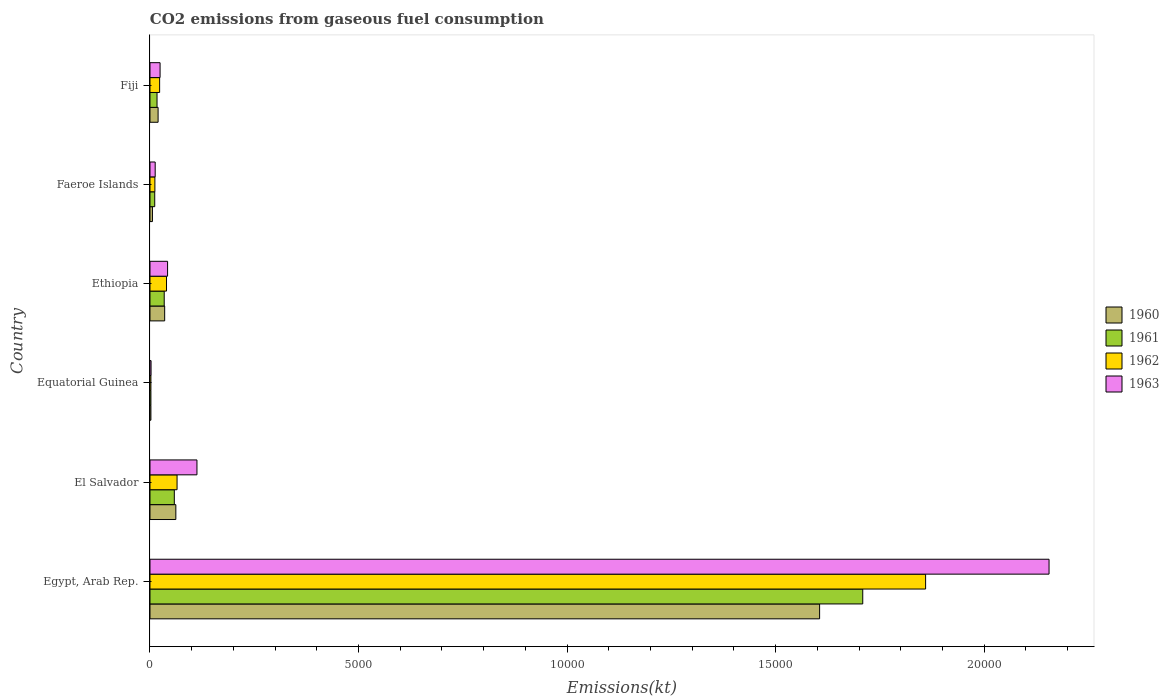Are the number of bars per tick equal to the number of legend labels?
Offer a terse response. Yes. How many bars are there on the 2nd tick from the bottom?
Your response must be concise. 4. What is the label of the 6th group of bars from the top?
Your answer should be very brief. Egypt, Arab Rep. In how many cases, is the number of bars for a given country not equal to the number of legend labels?
Offer a terse response. 0. What is the amount of CO2 emitted in 1961 in Egypt, Arab Rep.?
Offer a terse response. 1.71e+04. Across all countries, what is the maximum amount of CO2 emitted in 1960?
Offer a very short reply. 1.61e+04. Across all countries, what is the minimum amount of CO2 emitted in 1963?
Offer a terse response. 25.67. In which country was the amount of CO2 emitted in 1960 maximum?
Your answer should be very brief. Egypt, Arab Rep. In which country was the amount of CO2 emitted in 1962 minimum?
Offer a very short reply. Equatorial Guinea. What is the total amount of CO2 emitted in 1960 in the graph?
Your answer should be very brief. 1.73e+04. What is the difference between the amount of CO2 emitted in 1963 in Egypt, Arab Rep. and that in Fiji?
Offer a terse response. 2.13e+04. What is the difference between the amount of CO2 emitted in 1960 in Ethiopia and the amount of CO2 emitted in 1963 in Equatorial Guinea?
Your answer should be very brief. 326.36. What is the average amount of CO2 emitted in 1960 per country?
Your answer should be very brief. 2883.48. What is the difference between the amount of CO2 emitted in 1960 and amount of CO2 emitted in 1962 in Equatorial Guinea?
Provide a succinct answer. 0. In how many countries, is the amount of CO2 emitted in 1960 greater than 20000 kt?
Offer a terse response. 0. What is the ratio of the amount of CO2 emitted in 1961 in Equatorial Guinea to that in Ethiopia?
Give a very brief answer. 0.06. Is the difference between the amount of CO2 emitted in 1960 in Ethiopia and Faeroe Islands greater than the difference between the amount of CO2 emitted in 1962 in Ethiopia and Faeroe Islands?
Provide a short and direct response. Yes. What is the difference between the highest and the second highest amount of CO2 emitted in 1960?
Keep it short and to the point. 1.54e+04. What is the difference between the highest and the lowest amount of CO2 emitted in 1963?
Offer a very short reply. 2.15e+04. In how many countries, is the amount of CO2 emitted in 1961 greater than the average amount of CO2 emitted in 1961 taken over all countries?
Your response must be concise. 1. Is the sum of the amount of CO2 emitted in 1961 in El Salvador and Ethiopia greater than the maximum amount of CO2 emitted in 1963 across all countries?
Ensure brevity in your answer.  No. Is it the case that in every country, the sum of the amount of CO2 emitted in 1960 and amount of CO2 emitted in 1963 is greater than the sum of amount of CO2 emitted in 1961 and amount of CO2 emitted in 1962?
Provide a succinct answer. No. What does the 3rd bar from the top in Faeroe Islands represents?
Provide a short and direct response. 1961. Is it the case that in every country, the sum of the amount of CO2 emitted in 1960 and amount of CO2 emitted in 1962 is greater than the amount of CO2 emitted in 1961?
Your answer should be compact. Yes. How many bars are there?
Offer a very short reply. 24. What is the difference between two consecutive major ticks on the X-axis?
Your response must be concise. 5000. Are the values on the major ticks of X-axis written in scientific E-notation?
Your response must be concise. No. Does the graph contain any zero values?
Provide a succinct answer. No. Does the graph contain grids?
Offer a very short reply. No. Where does the legend appear in the graph?
Your response must be concise. Center right. How many legend labels are there?
Ensure brevity in your answer.  4. What is the title of the graph?
Your answer should be compact. CO2 emissions from gaseous fuel consumption. What is the label or title of the X-axis?
Ensure brevity in your answer.  Emissions(kt). What is the Emissions(kt) in 1960 in Egypt, Arab Rep.?
Your answer should be compact. 1.61e+04. What is the Emissions(kt) in 1961 in Egypt, Arab Rep.?
Make the answer very short. 1.71e+04. What is the Emissions(kt) in 1962 in Egypt, Arab Rep.?
Give a very brief answer. 1.86e+04. What is the Emissions(kt) of 1963 in Egypt, Arab Rep.?
Keep it short and to the point. 2.16e+04. What is the Emissions(kt) of 1960 in El Salvador?
Give a very brief answer. 619.72. What is the Emissions(kt) of 1961 in El Salvador?
Your response must be concise. 583.05. What is the Emissions(kt) of 1962 in El Salvador?
Your response must be concise. 649.06. What is the Emissions(kt) in 1963 in El Salvador?
Your answer should be very brief. 1125.77. What is the Emissions(kt) of 1960 in Equatorial Guinea?
Make the answer very short. 22. What is the Emissions(kt) in 1961 in Equatorial Guinea?
Your answer should be very brief. 22. What is the Emissions(kt) in 1962 in Equatorial Guinea?
Your answer should be very brief. 22. What is the Emissions(kt) of 1963 in Equatorial Guinea?
Your answer should be very brief. 25.67. What is the Emissions(kt) in 1960 in Ethiopia?
Offer a terse response. 352.03. What is the Emissions(kt) of 1961 in Ethiopia?
Provide a succinct answer. 341.03. What is the Emissions(kt) in 1962 in Ethiopia?
Keep it short and to the point. 396.04. What is the Emissions(kt) of 1963 in Ethiopia?
Make the answer very short. 421.7. What is the Emissions(kt) of 1960 in Faeroe Islands?
Offer a very short reply. 58.67. What is the Emissions(kt) in 1961 in Faeroe Islands?
Provide a short and direct response. 113.68. What is the Emissions(kt) in 1962 in Faeroe Islands?
Your answer should be very brief. 117.34. What is the Emissions(kt) in 1963 in Faeroe Islands?
Your response must be concise. 124.68. What is the Emissions(kt) in 1960 in Fiji?
Keep it short and to the point. 194.35. What is the Emissions(kt) in 1961 in Fiji?
Your answer should be compact. 168.68. What is the Emissions(kt) in 1962 in Fiji?
Offer a very short reply. 231.02. What is the Emissions(kt) in 1963 in Fiji?
Give a very brief answer. 242.02. Across all countries, what is the maximum Emissions(kt) in 1960?
Offer a very short reply. 1.61e+04. Across all countries, what is the maximum Emissions(kt) of 1961?
Provide a succinct answer. 1.71e+04. Across all countries, what is the maximum Emissions(kt) of 1962?
Provide a succinct answer. 1.86e+04. Across all countries, what is the maximum Emissions(kt) of 1963?
Offer a very short reply. 2.16e+04. Across all countries, what is the minimum Emissions(kt) in 1960?
Provide a short and direct response. 22. Across all countries, what is the minimum Emissions(kt) in 1961?
Provide a succinct answer. 22. Across all countries, what is the minimum Emissions(kt) in 1962?
Your answer should be very brief. 22. Across all countries, what is the minimum Emissions(kt) in 1963?
Give a very brief answer. 25.67. What is the total Emissions(kt) of 1960 in the graph?
Your response must be concise. 1.73e+04. What is the total Emissions(kt) in 1961 in the graph?
Make the answer very short. 1.83e+04. What is the total Emissions(kt) in 1962 in the graph?
Provide a short and direct response. 2.00e+04. What is the total Emissions(kt) of 1963 in the graph?
Your answer should be compact. 2.35e+04. What is the difference between the Emissions(kt) of 1960 in Egypt, Arab Rep. and that in El Salvador?
Provide a short and direct response. 1.54e+04. What is the difference between the Emissions(kt) in 1961 in Egypt, Arab Rep. and that in El Salvador?
Keep it short and to the point. 1.65e+04. What is the difference between the Emissions(kt) of 1962 in Egypt, Arab Rep. and that in El Salvador?
Your answer should be compact. 1.79e+04. What is the difference between the Emissions(kt) in 1963 in Egypt, Arab Rep. and that in El Salvador?
Offer a very short reply. 2.04e+04. What is the difference between the Emissions(kt) of 1960 in Egypt, Arab Rep. and that in Equatorial Guinea?
Ensure brevity in your answer.  1.60e+04. What is the difference between the Emissions(kt) in 1961 in Egypt, Arab Rep. and that in Equatorial Guinea?
Give a very brief answer. 1.71e+04. What is the difference between the Emissions(kt) in 1962 in Egypt, Arab Rep. and that in Equatorial Guinea?
Your answer should be very brief. 1.86e+04. What is the difference between the Emissions(kt) in 1963 in Egypt, Arab Rep. and that in Equatorial Guinea?
Your response must be concise. 2.15e+04. What is the difference between the Emissions(kt) in 1960 in Egypt, Arab Rep. and that in Ethiopia?
Offer a very short reply. 1.57e+04. What is the difference between the Emissions(kt) in 1961 in Egypt, Arab Rep. and that in Ethiopia?
Ensure brevity in your answer.  1.67e+04. What is the difference between the Emissions(kt) in 1962 in Egypt, Arab Rep. and that in Ethiopia?
Your response must be concise. 1.82e+04. What is the difference between the Emissions(kt) in 1963 in Egypt, Arab Rep. and that in Ethiopia?
Offer a very short reply. 2.11e+04. What is the difference between the Emissions(kt) of 1960 in Egypt, Arab Rep. and that in Faeroe Islands?
Offer a terse response. 1.60e+04. What is the difference between the Emissions(kt) in 1961 in Egypt, Arab Rep. and that in Faeroe Islands?
Ensure brevity in your answer.  1.70e+04. What is the difference between the Emissions(kt) in 1962 in Egypt, Arab Rep. and that in Faeroe Islands?
Give a very brief answer. 1.85e+04. What is the difference between the Emissions(kt) in 1963 in Egypt, Arab Rep. and that in Faeroe Islands?
Offer a very short reply. 2.14e+04. What is the difference between the Emissions(kt) in 1960 in Egypt, Arab Rep. and that in Fiji?
Your answer should be compact. 1.59e+04. What is the difference between the Emissions(kt) of 1961 in Egypt, Arab Rep. and that in Fiji?
Your answer should be compact. 1.69e+04. What is the difference between the Emissions(kt) of 1962 in Egypt, Arab Rep. and that in Fiji?
Give a very brief answer. 1.84e+04. What is the difference between the Emissions(kt) of 1963 in Egypt, Arab Rep. and that in Fiji?
Offer a terse response. 2.13e+04. What is the difference between the Emissions(kt) in 1960 in El Salvador and that in Equatorial Guinea?
Provide a short and direct response. 597.72. What is the difference between the Emissions(kt) in 1961 in El Salvador and that in Equatorial Guinea?
Offer a very short reply. 561.05. What is the difference between the Emissions(kt) in 1962 in El Salvador and that in Equatorial Guinea?
Keep it short and to the point. 627.06. What is the difference between the Emissions(kt) of 1963 in El Salvador and that in Equatorial Guinea?
Provide a succinct answer. 1100.1. What is the difference between the Emissions(kt) in 1960 in El Salvador and that in Ethiopia?
Your response must be concise. 267.69. What is the difference between the Emissions(kt) in 1961 in El Salvador and that in Ethiopia?
Make the answer very short. 242.02. What is the difference between the Emissions(kt) in 1962 in El Salvador and that in Ethiopia?
Your response must be concise. 253.02. What is the difference between the Emissions(kt) in 1963 in El Salvador and that in Ethiopia?
Your response must be concise. 704.06. What is the difference between the Emissions(kt) of 1960 in El Salvador and that in Faeroe Islands?
Ensure brevity in your answer.  561.05. What is the difference between the Emissions(kt) of 1961 in El Salvador and that in Faeroe Islands?
Your answer should be very brief. 469.38. What is the difference between the Emissions(kt) of 1962 in El Salvador and that in Faeroe Islands?
Keep it short and to the point. 531.72. What is the difference between the Emissions(kt) in 1963 in El Salvador and that in Faeroe Islands?
Offer a terse response. 1001.09. What is the difference between the Emissions(kt) in 1960 in El Salvador and that in Fiji?
Make the answer very short. 425.37. What is the difference between the Emissions(kt) in 1961 in El Salvador and that in Fiji?
Offer a terse response. 414.37. What is the difference between the Emissions(kt) in 1962 in El Salvador and that in Fiji?
Offer a very short reply. 418.04. What is the difference between the Emissions(kt) of 1963 in El Salvador and that in Fiji?
Your answer should be compact. 883.75. What is the difference between the Emissions(kt) in 1960 in Equatorial Guinea and that in Ethiopia?
Give a very brief answer. -330.03. What is the difference between the Emissions(kt) of 1961 in Equatorial Guinea and that in Ethiopia?
Give a very brief answer. -319.03. What is the difference between the Emissions(kt) in 1962 in Equatorial Guinea and that in Ethiopia?
Ensure brevity in your answer.  -374.03. What is the difference between the Emissions(kt) of 1963 in Equatorial Guinea and that in Ethiopia?
Provide a short and direct response. -396.04. What is the difference between the Emissions(kt) in 1960 in Equatorial Guinea and that in Faeroe Islands?
Give a very brief answer. -36.67. What is the difference between the Emissions(kt) in 1961 in Equatorial Guinea and that in Faeroe Islands?
Offer a very short reply. -91.67. What is the difference between the Emissions(kt) in 1962 in Equatorial Guinea and that in Faeroe Islands?
Give a very brief answer. -95.34. What is the difference between the Emissions(kt) in 1963 in Equatorial Guinea and that in Faeroe Islands?
Your response must be concise. -99.01. What is the difference between the Emissions(kt) of 1960 in Equatorial Guinea and that in Fiji?
Give a very brief answer. -172.35. What is the difference between the Emissions(kt) in 1961 in Equatorial Guinea and that in Fiji?
Ensure brevity in your answer.  -146.68. What is the difference between the Emissions(kt) in 1962 in Equatorial Guinea and that in Fiji?
Give a very brief answer. -209.02. What is the difference between the Emissions(kt) in 1963 in Equatorial Guinea and that in Fiji?
Offer a terse response. -216.35. What is the difference between the Emissions(kt) in 1960 in Ethiopia and that in Faeroe Islands?
Provide a short and direct response. 293.36. What is the difference between the Emissions(kt) in 1961 in Ethiopia and that in Faeroe Islands?
Provide a short and direct response. 227.35. What is the difference between the Emissions(kt) in 1962 in Ethiopia and that in Faeroe Islands?
Provide a short and direct response. 278.69. What is the difference between the Emissions(kt) in 1963 in Ethiopia and that in Faeroe Islands?
Your response must be concise. 297.03. What is the difference between the Emissions(kt) in 1960 in Ethiopia and that in Fiji?
Your answer should be compact. 157.68. What is the difference between the Emissions(kt) of 1961 in Ethiopia and that in Fiji?
Make the answer very short. 172.35. What is the difference between the Emissions(kt) in 1962 in Ethiopia and that in Fiji?
Make the answer very short. 165.01. What is the difference between the Emissions(kt) in 1963 in Ethiopia and that in Fiji?
Your answer should be compact. 179.68. What is the difference between the Emissions(kt) in 1960 in Faeroe Islands and that in Fiji?
Offer a terse response. -135.68. What is the difference between the Emissions(kt) in 1961 in Faeroe Islands and that in Fiji?
Make the answer very short. -55.01. What is the difference between the Emissions(kt) of 1962 in Faeroe Islands and that in Fiji?
Offer a terse response. -113.68. What is the difference between the Emissions(kt) of 1963 in Faeroe Islands and that in Fiji?
Your response must be concise. -117.34. What is the difference between the Emissions(kt) in 1960 in Egypt, Arab Rep. and the Emissions(kt) in 1961 in El Salvador?
Your response must be concise. 1.55e+04. What is the difference between the Emissions(kt) of 1960 in Egypt, Arab Rep. and the Emissions(kt) of 1962 in El Salvador?
Give a very brief answer. 1.54e+04. What is the difference between the Emissions(kt) in 1960 in Egypt, Arab Rep. and the Emissions(kt) in 1963 in El Salvador?
Your answer should be compact. 1.49e+04. What is the difference between the Emissions(kt) of 1961 in Egypt, Arab Rep. and the Emissions(kt) of 1962 in El Salvador?
Keep it short and to the point. 1.64e+04. What is the difference between the Emissions(kt) of 1961 in Egypt, Arab Rep. and the Emissions(kt) of 1963 in El Salvador?
Give a very brief answer. 1.60e+04. What is the difference between the Emissions(kt) of 1962 in Egypt, Arab Rep. and the Emissions(kt) of 1963 in El Salvador?
Ensure brevity in your answer.  1.75e+04. What is the difference between the Emissions(kt) in 1960 in Egypt, Arab Rep. and the Emissions(kt) in 1961 in Equatorial Guinea?
Your answer should be compact. 1.60e+04. What is the difference between the Emissions(kt) of 1960 in Egypt, Arab Rep. and the Emissions(kt) of 1962 in Equatorial Guinea?
Offer a terse response. 1.60e+04. What is the difference between the Emissions(kt) of 1960 in Egypt, Arab Rep. and the Emissions(kt) of 1963 in Equatorial Guinea?
Offer a very short reply. 1.60e+04. What is the difference between the Emissions(kt) in 1961 in Egypt, Arab Rep. and the Emissions(kt) in 1962 in Equatorial Guinea?
Your response must be concise. 1.71e+04. What is the difference between the Emissions(kt) in 1961 in Egypt, Arab Rep. and the Emissions(kt) in 1963 in Equatorial Guinea?
Your response must be concise. 1.71e+04. What is the difference between the Emissions(kt) in 1962 in Egypt, Arab Rep. and the Emissions(kt) in 1963 in Equatorial Guinea?
Your response must be concise. 1.86e+04. What is the difference between the Emissions(kt) of 1960 in Egypt, Arab Rep. and the Emissions(kt) of 1961 in Ethiopia?
Your answer should be compact. 1.57e+04. What is the difference between the Emissions(kt) of 1960 in Egypt, Arab Rep. and the Emissions(kt) of 1962 in Ethiopia?
Offer a terse response. 1.57e+04. What is the difference between the Emissions(kt) in 1960 in Egypt, Arab Rep. and the Emissions(kt) in 1963 in Ethiopia?
Give a very brief answer. 1.56e+04. What is the difference between the Emissions(kt) in 1961 in Egypt, Arab Rep. and the Emissions(kt) in 1962 in Ethiopia?
Keep it short and to the point. 1.67e+04. What is the difference between the Emissions(kt) in 1961 in Egypt, Arab Rep. and the Emissions(kt) in 1963 in Ethiopia?
Keep it short and to the point. 1.67e+04. What is the difference between the Emissions(kt) of 1962 in Egypt, Arab Rep. and the Emissions(kt) of 1963 in Ethiopia?
Ensure brevity in your answer.  1.82e+04. What is the difference between the Emissions(kt) of 1960 in Egypt, Arab Rep. and the Emissions(kt) of 1961 in Faeroe Islands?
Offer a terse response. 1.59e+04. What is the difference between the Emissions(kt) of 1960 in Egypt, Arab Rep. and the Emissions(kt) of 1962 in Faeroe Islands?
Offer a very short reply. 1.59e+04. What is the difference between the Emissions(kt) of 1960 in Egypt, Arab Rep. and the Emissions(kt) of 1963 in Faeroe Islands?
Your answer should be compact. 1.59e+04. What is the difference between the Emissions(kt) in 1961 in Egypt, Arab Rep. and the Emissions(kt) in 1962 in Faeroe Islands?
Offer a terse response. 1.70e+04. What is the difference between the Emissions(kt) in 1961 in Egypt, Arab Rep. and the Emissions(kt) in 1963 in Faeroe Islands?
Your answer should be compact. 1.70e+04. What is the difference between the Emissions(kt) in 1962 in Egypt, Arab Rep. and the Emissions(kt) in 1963 in Faeroe Islands?
Provide a short and direct response. 1.85e+04. What is the difference between the Emissions(kt) in 1960 in Egypt, Arab Rep. and the Emissions(kt) in 1961 in Fiji?
Provide a short and direct response. 1.59e+04. What is the difference between the Emissions(kt) in 1960 in Egypt, Arab Rep. and the Emissions(kt) in 1962 in Fiji?
Your answer should be compact. 1.58e+04. What is the difference between the Emissions(kt) in 1960 in Egypt, Arab Rep. and the Emissions(kt) in 1963 in Fiji?
Provide a short and direct response. 1.58e+04. What is the difference between the Emissions(kt) in 1961 in Egypt, Arab Rep. and the Emissions(kt) in 1962 in Fiji?
Ensure brevity in your answer.  1.69e+04. What is the difference between the Emissions(kt) of 1961 in Egypt, Arab Rep. and the Emissions(kt) of 1963 in Fiji?
Provide a short and direct response. 1.68e+04. What is the difference between the Emissions(kt) of 1962 in Egypt, Arab Rep. and the Emissions(kt) of 1963 in Fiji?
Offer a terse response. 1.84e+04. What is the difference between the Emissions(kt) in 1960 in El Salvador and the Emissions(kt) in 1961 in Equatorial Guinea?
Offer a terse response. 597.72. What is the difference between the Emissions(kt) in 1960 in El Salvador and the Emissions(kt) in 1962 in Equatorial Guinea?
Provide a short and direct response. 597.72. What is the difference between the Emissions(kt) in 1960 in El Salvador and the Emissions(kt) in 1963 in Equatorial Guinea?
Your response must be concise. 594.05. What is the difference between the Emissions(kt) of 1961 in El Salvador and the Emissions(kt) of 1962 in Equatorial Guinea?
Make the answer very short. 561.05. What is the difference between the Emissions(kt) of 1961 in El Salvador and the Emissions(kt) of 1963 in Equatorial Guinea?
Your answer should be very brief. 557.38. What is the difference between the Emissions(kt) in 1962 in El Salvador and the Emissions(kt) in 1963 in Equatorial Guinea?
Your answer should be very brief. 623.39. What is the difference between the Emissions(kt) of 1960 in El Salvador and the Emissions(kt) of 1961 in Ethiopia?
Give a very brief answer. 278.69. What is the difference between the Emissions(kt) of 1960 in El Salvador and the Emissions(kt) of 1962 in Ethiopia?
Your response must be concise. 223.69. What is the difference between the Emissions(kt) in 1960 in El Salvador and the Emissions(kt) in 1963 in Ethiopia?
Ensure brevity in your answer.  198.02. What is the difference between the Emissions(kt) of 1961 in El Salvador and the Emissions(kt) of 1962 in Ethiopia?
Make the answer very short. 187.02. What is the difference between the Emissions(kt) in 1961 in El Salvador and the Emissions(kt) in 1963 in Ethiopia?
Make the answer very short. 161.35. What is the difference between the Emissions(kt) of 1962 in El Salvador and the Emissions(kt) of 1963 in Ethiopia?
Offer a very short reply. 227.35. What is the difference between the Emissions(kt) of 1960 in El Salvador and the Emissions(kt) of 1961 in Faeroe Islands?
Your response must be concise. 506.05. What is the difference between the Emissions(kt) in 1960 in El Salvador and the Emissions(kt) in 1962 in Faeroe Islands?
Ensure brevity in your answer.  502.38. What is the difference between the Emissions(kt) of 1960 in El Salvador and the Emissions(kt) of 1963 in Faeroe Islands?
Provide a short and direct response. 495.05. What is the difference between the Emissions(kt) of 1961 in El Salvador and the Emissions(kt) of 1962 in Faeroe Islands?
Provide a short and direct response. 465.71. What is the difference between the Emissions(kt) of 1961 in El Salvador and the Emissions(kt) of 1963 in Faeroe Islands?
Your answer should be very brief. 458.38. What is the difference between the Emissions(kt) in 1962 in El Salvador and the Emissions(kt) in 1963 in Faeroe Islands?
Your answer should be very brief. 524.38. What is the difference between the Emissions(kt) in 1960 in El Salvador and the Emissions(kt) in 1961 in Fiji?
Your answer should be compact. 451.04. What is the difference between the Emissions(kt) in 1960 in El Salvador and the Emissions(kt) in 1962 in Fiji?
Your answer should be very brief. 388.7. What is the difference between the Emissions(kt) of 1960 in El Salvador and the Emissions(kt) of 1963 in Fiji?
Provide a succinct answer. 377.7. What is the difference between the Emissions(kt) in 1961 in El Salvador and the Emissions(kt) in 1962 in Fiji?
Ensure brevity in your answer.  352.03. What is the difference between the Emissions(kt) in 1961 in El Salvador and the Emissions(kt) in 1963 in Fiji?
Ensure brevity in your answer.  341.03. What is the difference between the Emissions(kt) in 1962 in El Salvador and the Emissions(kt) in 1963 in Fiji?
Your response must be concise. 407.04. What is the difference between the Emissions(kt) of 1960 in Equatorial Guinea and the Emissions(kt) of 1961 in Ethiopia?
Your response must be concise. -319.03. What is the difference between the Emissions(kt) in 1960 in Equatorial Guinea and the Emissions(kt) in 1962 in Ethiopia?
Your answer should be compact. -374.03. What is the difference between the Emissions(kt) of 1960 in Equatorial Guinea and the Emissions(kt) of 1963 in Ethiopia?
Ensure brevity in your answer.  -399.7. What is the difference between the Emissions(kt) in 1961 in Equatorial Guinea and the Emissions(kt) in 1962 in Ethiopia?
Offer a very short reply. -374.03. What is the difference between the Emissions(kt) in 1961 in Equatorial Guinea and the Emissions(kt) in 1963 in Ethiopia?
Give a very brief answer. -399.7. What is the difference between the Emissions(kt) of 1962 in Equatorial Guinea and the Emissions(kt) of 1963 in Ethiopia?
Keep it short and to the point. -399.7. What is the difference between the Emissions(kt) of 1960 in Equatorial Guinea and the Emissions(kt) of 1961 in Faeroe Islands?
Ensure brevity in your answer.  -91.67. What is the difference between the Emissions(kt) of 1960 in Equatorial Guinea and the Emissions(kt) of 1962 in Faeroe Islands?
Offer a very short reply. -95.34. What is the difference between the Emissions(kt) in 1960 in Equatorial Guinea and the Emissions(kt) in 1963 in Faeroe Islands?
Provide a succinct answer. -102.68. What is the difference between the Emissions(kt) in 1961 in Equatorial Guinea and the Emissions(kt) in 1962 in Faeroe Islands?
Provide a short and direct response. -95.34. What is the difference between the Emissions(kt) in 1961 in Equatorial Guinea and the Emissions(kt) in 1963 in Faeroe Islands?
Keep it short and to the point. -102.68. What is the difference between the Emissions(kt) in 1962 in Equatorial Guinea and the Emissions(kt) in 1963 in Faeroe Islands?
Make the answer very short. -102.68. What is the difference between the Emissions(kt) of 1960 in Equatorial Guinea and the Emissions(kt) of 1961 in Fiji?
Provide a short and direct response. -146.68. What is the difference between the Emissions(kt) of 1960 in Equatorial Guinea and the Emissions(kt) of 1962 in Fiji?
Offer a very short reply. -209.02. What is the difference between the Emissions(kt) in 1960 in Equatorial Guinea and the Emissions(kt) in 1963 in Fiji?
Offer a terse response. -220.02. What is the difference between the Emissions(kt) of 1961 in Equatorial Guinea and the Emissions(kt) of 1962 in Fiji?
Ensure brevity in your answer.  -209.02. What is the difference between the Emissions(kt) of 1961 in Equatorial Guinea and the Emissions(kt) of 1963 in Fiji?
Make the answer very short. -220.02. What is the difference between the Emissions(kt) in 1962 in Equatorial Guinea and the Emissions(kt) in 1963 in Fiji?
Provide a short and direct response. -220.02. What is the difference between the Emissions(kt) in 1960 in Ethiopia and the Emissions(kt) in 1961 in Faeroe Islands?
Provide a succinct answer. 238.35. What is the difference between the Emissions(kt) of 1960 in Ethiopia and the Emissions(kt) of 1962 in Faeroe Islands?
Offer a very short reply. 234.69. What is the difference between the Emissions(kt) in 1960 in Ethiopia and the Emissions(kt) in 1963 in Faeroe Islands?
Your response must be concise. 227.35. What is the difference between the Emissions(kt) of 1961 in Ethiopia and the Emissions(kt) of 1962 in Faeroe Islands?
Your answer should be compact. 223.69. What is the difference between the Emissions(kt) of 1961 in Ethiopia and the Emissions(kt) of 1963 in Faeroe Islands?
Provide a short and direct response. 216.35. What is the difference between the Emissions(kt) of 1962 in Ethiopia and the Emissions(kt) of 1963 in Faeroe Islands?
Make the answer very short. 271.36. What is the difference between the Emissions(kt) in 1960 in Ethiopia and the Emissions(kt) in 1961 in Fiji?
Your answer should be compact. 183.35. What is the difference between the Emissions(kt) of 1960 in Ethiopia and the Emissions(kt) of 1962 in Fiji?
Ensure brevity in your answer.  121.01. What is the difference between the Emissions(kt) in 1960 in Ethiopia and the Emissions(kt) in 1963 in Fiji?
Offer a terse response. 110.01. What is the difference between the Emissions(kt) of 1961 in Ethiopia and the Emissions(kt) of 1962 in Fiji?
Make the answer very short. 110.01. What is the difference between the Emissions(kt) in 1961 in Ethiopia and the Emissions(kt) in 1963 in Fiji?
Keep it short and to the point. 99.01. What is the difference between the Emissions(kt) of 1962 in Ethiopia and the Emissions(kt) of 1963 in Fiji?
Make the answer very short. 154.01. What is the difference between the Emissions(kt) in 1960 in Faeroe Islands and the Emissions(kt) in 1961 in Fiji?
Ensure brevity in your answer.  -110.01. What is the difference between the Emissions(kt) in 1960 in Faeroe Islands and the Emissions(kt) in 1962 in Fiji?
Your response must be concise. -172.35. What is the difference between the Emissions(kt) in 1960 in Faeroe Islands and the Emissions(kt) in 1963 in Fiji?
Your answer should be very brief. -183.35. What is the difference between the Emissions(kt) of 1961 in Faeroe Islands and the Emissions(kt) of 1962 in Fiji?
Your response must be concise. -117.34. What is the difference between the Emissions(kt) in 1961 in Faeroe Islands and the Emissions(kt) in 1963 in Fiji?
Keep it short and to the point. -128.34. What is the difference between the Emissions(kt) of 1962 in Faeroe Islands and the Emissions(kt) of 1963 in Fiji?
Make the answer very short. -124.68. What is the average Emissions(kt) of 1960 per country?
Make the answer very short. 2883.48. What is the average Emissions(kt) of 1961 per country?
Your answer should be very brief. 3052.78. What is the average Emissions(kt) in 1962 per country?
Your answer should be compact. 3335.14. What is the average Emissions(kt) of 1963 per country?
Make the answer very short. 3915.74. What is the difference between the Emissions(kt) of 1960 and Emissions(kt) of 1961 in Egypt, Arab Rep.?
Give a very brief answer. -1034.09. What is the difference between the Emissions(kt) in 1960 and Emissions(kt) in 1962 in Egypt, Arab Rep.?
Ensure brevity in your answer.  -2541.23. What is the difference between the Emissions(kt) in 1960 and Emissions(kt) in 1963 in Egypt, Arab Rep.?
Your response must be concise. -5500.5. What is the difference between the Emissions(kt) of 1961 and Emissions(kt) of 1962 in Egypt, Arab Rep.?
Offer a terse response. -1507.14. What is the difference between the Emissions(kt) in 1961 and Emissions(kt) in 1963 in Egypt, Arab Rep.?
Your answer should be very brief. -4466.41. What is the difference between the Emissions(kt) of 1962 and Emissions(kt) of 1963 in Egypt, Arab Rep.?
Your answer should be compact. -2959.27. What is the difference between the Emissions(kt) of 1960 and Emissions(kt) of 1961 in El Salvador?
Provide a short and direct response. 36.67. What is the difference between the Emissions(kt) in 1960 and Emissions(kt) in 1962 in El Salvador?
Offer a very short reply. -29.34. What is the difference between the Emissions(kt) of 1960 and Emissions(kt) of 1963 in El Salvador?
Give a very brief answer. -506.05. What is the difference between the Emissions(kt) of 1961 and Emissions(kt) of 1962 in El Salvador?
Offer a terse response. -66.01. What is the difference between the Emissions(kt) in 1961 and Emissions(kt) in 1963 in El Salvador?
Give a very brief answer. -542.72. What is the difference between the Emissions(kt) in 1962 and Emissions(kt) in 1963 in El Salvador?
Provide a succinct answer. -476.71. What is the difference between the Emissions(kt) of 1960 and Emissions(kt) of 1961 in Equatorial Guinea?
Provide a short and direct response. 0. What is the difference between the Emissions(kt) in 1960 and Emissions(kt) in 1963 in Equatorial Guinea?
Your response must be concise. -3.67. What is the difference between the Emissions(kt) in 1961 and Emissions(kt) in 1962 in Equatorial Guinea?
Your answer should be very brief. 0. What is the difference between the Emissions(kt) of 1961 and Emissions(kt) of 1963 in Equatorial Guinea?
Provide a succinct answer. -3.67. What is the difference between the Emissions(kt) in 1962 and Emissions(kt) in 1963 in Equatorial Guinea?
Your answer should be compact. -3.67. What is the difference between the Emissions(kt) in 1960 and Emissions(kt) in 1961 in Ethiopia?
Ensure brevity in your answer.  11. What is the difference between the Emissions(kt) of 1960 and Emissions(kt) of 1962 in Ethiopia?
Provide a short and direct response. -44. What is the difference between the Emissions(kt) in 1960 and Emissions(kt) in 1963 in Ethiopia?
Give a very brief answer. -69.67. What is the difference between the Emissions(kt) in 1961 and Emissions(kt) in 1962 in Ethiopia?
Your response must be concise. -55.01. What is the difference between the Emissions(kt) of 1961 and Emissions(kt) of 1963 in Ethiopia?
Provide a short and direct response. -80.67. What is the difference between the Emissions(kt) in 1962 and Emissions(kt) in 1963 in Ethiopia?
Provide a succinct answer. -25.67. What is the difference between the Emissions(kt) of 1960 and Emissions(kt) of 1961 in Faeroe Islands?
Provide a succinct answer. -55.01. What is the difference between the Emissions(kt) in 1960 and Emissions(kt) in 1962 in Faeroe Islands?
Offer a very short reply. -58.67. What is the difference between the Emissions(kt) in 1960 and Emissions(kt) in 1963 in Faeroe Islands?
Offer a terse response. -66.01. What is the difference between the Emissions(kt) of 1961 and Emissions(kt) of 1962 in Faeroe Islands?
Your response must be concise. -3.67. What is the difference between the Emissions(kt) in 1961 and Emissions(kt) in 1963 in Faeroe Islands?
Ensure brevity in your answer.  -11. What is the difference between the Emissions(kt) in 1962 and Emissions(kt) in 1963 in Faeroe Islands?
Offer a very short reply. -7.33. What is the difference between the Emissions(kt) of 1960 and Emissions(kt) of 1961 in Fiji?
Keep it short and to the point. 25.67. What is the difference between the Emissions(kt) of 1960 and Emissions(kt) of 1962 in Fiji?
Offer a very short reply. -36.67. What is the difference between the Emissions(kt) in 1960 and Emissions(kt) in 1963 in Fiji?
Provide a short and direct response. -47.67. What is the difference between the Emissions(kt) in 1961 and Emissions(kt) in 1962 in Fiji?
Make the answer very short. -62.34. What is the difference between the Emissions(kt) of 1961 and Emissions(kt) of 1963 in Fiji?
Your response must be concise. -73.34. What is the difference between the Emissions(kt) of 1962 and Emissions(kt) of 1963 in Fiji?
Give a very brief answer. -11. What is the ratio of the Emissions(kt) of 1960 in Egypt, Arab Rep. to that in El Salvador?
Your answer should be compact. 25.91. What is the ratio of the Emissions(kt) in 1961 in Egypt, Arab Rep. to that in El Salvador?
Provide a succinct answer. 29.31. What is the ratio of the Emissions(kt) in 1962 in Egypt, Arab Rep. to that in El Salvador?
Offer a very short reply. 28.65. What is the ratio of the Emissions(kt) of 1963 in Egypt, Arab Rep. to that in El Salvador?
Ensure brevity in your answer.  19.15. What is the ratio of the Emissions(kt) of 1960 in Egypt, Arab Rep. to that in Equatorial Guinea?
Give a very brief answer. 729.67. What is the ratio of the Emissions(kt) in 1961 in Egypt, Arab Rep. to that in Equatorial Guinea?
Provide a short and direct response. 776.67. What is the ratio of the Emissions(kt) of 1962 in Egypt, Arab Rep. to that in Equatorial Guinea?
Ensure brevity in your answer.  845.17. What is the ratio of the Emissions(kt) in 1963 in Egypt, Arab Rep. to that in Equatorial Guinea?
Provide a short and direct response. 839.71. What is the ratio of the Emissions(kt) in 1960 in Egypt, Arab Rep. to that in Ethiopia?
Provide a short and direct response. 45.6. What is the ratio of the Emissions(kt) of 1961 in Egypt, Arab Rep. to that in Ethiopia?
Provide a succinct answer. 50.11. What is the ratio of the Emissions(kt) in 1962 in Egypt, Arab Rep. to that in Ethiopia?
Provide a short and direct response. 46.95. What is the ratio of the Emissions(kt) in 1963 in Egypt, Arab Rep. to that in Ethiopia?
Provide a short and direct response. 51.11. What is the ratio of the Emissions(kt) in 1960 in Egypt, Arab Rep. to that in Faeroe Islands?
Your answer should be very brief. 273.62. What is the ratio of the Emissions(kt) in 1961 in Egypt, Arab Rep. to that in Faeroe Islands?
Give a very brief answer. 150.32. What is the ratio of the Emissions(kt) in 1962 in Egypt, Arab Rep. to that in Faeroe Islands?
Offer a terse response. 158.47. What is the ratio of the Emissions(kt) of 1963 in Egypt, Arab Rep. to that in Faeroe Islands?
Ensure brevity in your answer.  172.88. What is the ratio of the Emissions(kt) in 1960 in Egypt, Arab Rep. to that in Fiji?
Offer a terse response. 82.6. What is the ratio of the Emissions(kt) of 1961 in Egypt, Arab Rep. to that in Fiji?
Keep it short and to the point. 101.3. What is the ratio of the Emissions(kt) of 1962 in Egypt, Arab Rep. to that in Fiji?
Ensure brevity in your answer.  80.49. What is the ratio of the Emissions(kt) of 1963 in Egypt, Arab Rep. to that in Fiji?
Make the answer very short. 89.06. What is the ratio of the Emissions(kt) in 1960 in El Salvador to that in Equatorial Guinea?
Your answer should be compact. 28.17. What is the ratio of the Emissions(kt) in 1961 in El Salvador to that in Equatorial Guinea?
Your answer should be compact. 26.5. What is the ratio of the Emissions(kt) of 1962 in El Salvador to that in Equatorial Guinea?
Provide a succinct answer. 29.5. What is the ratio of the Emissions(kt) in 1963 in El Salvador to that in Equatorial Guinea?
Give a very brief answer. 43.86. What is the ratio of the Emissions(kt) of 1960 in El Salvador to that in Ethiopia?
Provide a short and direct response. 1.76. What is the ratio of the Emissions(kt) in 1961 in El Salvador to that in Ethiopia?
Your answer should be very brief. 1.71. What is the ratio of the Emissions(kt) of 1962 in El Salvador to that in Ethiopia?
Give a very brief answer. 1.64. What is the ratio of the Emissions(kt) of 1963 in El Salvador to that in Ethiopia?
Make the answer very short. 2.67. What is the ratio of the Emissions(kt) in 1960 in El Salvador to that in Faeroe Islands?
Offer a very short reply. 10.56. What is the ratio of the Emissions(kt) of 1961 in El Salvador to that in Faeroe Islands?
Provide a short and direct response. 5.13. What is the ratio of the Emissions(kt) in 1962 in El Salvador to that in Faeroe Islands?
Your answer should be very brief. 5.53. What is the ratio of the Emissions(kt) in 1963 in El Salvador to that in Faeroe Islands?
Make the answer very short. 9.03. What is the ratio of the Emissions(kt) of 1960 in El Salvador to that in Fiji?
Your answer should be compact. 3.19. What is the ratio of the Emissions(kt) of 1961 in El Salvador to that in Fiji?
Your response must be concise. 3.46. What is the ratio of the Emissions(kt) in 1962 in El Salvador to that in Fiji?
Give a very brief answer. 2.81. What is the ratio of the Emissions(kt) of 1963 in El Salvador to that in Fiji?
Make the answer very short. 4.65. What is the ratio of the Emissions(kt) in 1960 in Equatorial Guinea to that in Ethiopia?
Your response must be concise. 0.06. What is the ratio of the Emissions(kt) of 1961 in Equatorial Guinea to that in Ethiopia?
Your answer should be very brief. 0.06. What is the ratio of the Emissions(kt) in 1962 in Equatorial Guinea to that in Ethiopia?
Keep it short and to the point. 0.06. What is the ratio of the Emissions(kt) in 1963 in Equatorial Guinea to that in Ethiopia?
Make the answer very short. 0.06. What is the ratio of the Emissions(kt) in 1960 in Equatorial Guinea to that in Faeroe Islands?
Offer a very short reply. 0.38. What is the ratio of the Emissions(kt) of 1961 in Equatorial Guinea to that in Faeroe Islands?
Your answer should be very brief. 0.19. What is the ratio of the Emissions(kt) in 1962 in Equatorial Guinea to that in Faeroe Islands?
Provide a short and direct response. 0.19. What is the ratio of the Emissions(kt) in 1963 in Equatorial Guinea to that in Faeroe Islands?
Make the answer very short. 0.21. What is the ratio of the Emissions(kt) in 1960 in Equatorial Guinea to that in Fiji?
Your response must be concise. 0.11. What is the ratio of the Emissions(kt) of 1961 in Equatorial Guinea to that in Fiji?
Ensure brevity in your answer.  0.13. What is the ratio of the Emissions(kt) in 1962 in Equatorial Guinea to that in Fiji?
Provide a succinct answer. 0.1. What is the ratio of the Emissions(kt) in 1963 in Equatorial Guinea to that in Fiji?
Make the answer very short. 0.11. What is the ratio of the Emissions(kt) in 1960 in Ethiopia to that in Faeroe Islands?
Give a very brief answer. 6. What is the ratio of the Emissions(kt) in 1961 in Ethiopia to that in Faeroe Islands?
Keep it short and to the point. 3. What is the ratio of the Emissions(kt) of 1962 in Ethiopia to that in Faeroe Islands?
Offer a very short reply. 3.38. What is the ratio of the Emissions(kt) in 1963 in Ethiopia to that in Faeroe Islands?
Offer a very short reply. 3.38. What is the ratio of the Emissions(kt) of 1960 in Ethiopia to that in Fiji?
Offer a terse response. 1.81. What is the ratio of the Emissions(kt) of 1961 in Ethiopia to that in Fiji?
Keep it short and to the point. 2.02. What is the ratio of the Emissions(kt) of 1962 in Ethiopia to that in Fiji?
Provide a short and direct response. 1.71. What is the ratio of the Emissions(kt) in 1963 in Ethiopia to that in Fiji?
Offer a very short reply. 1.74. What is the ratio of the Emissions(kt) of 1960 in Faeroe Islands to that in Fiji?
Provide a succinct answer. 0.3. What is the ratio of the Emissions(kt) of 1961 in Faeroe Islands to that in Fiji?
Keep it short and to the point. 0.67. What is the ratio of the Emissions(kt) in 1962 in Faeroe Islands to that in Fiji?
Offer a terse response. 0.51. What is the ratio of the Emissions(kt) of 1963 in Faeroe Islands to that in Fiji?
Your answer should be very brief. 0.52. What is the difference between the highest and the second highest Emissions(kt) in 1960?
Provide a succinct answer. 1.54e+04. What is the difference between the highest and the second highest Emissions(kt) of 1961?
Your answer should be compact. 1.65e+04. What is the difference between the highest and the second highest Emissions(kt) of 1962?
Keep it short and to the point. 1.79e+04. What is the difference between the highest and the second highest Emissions(kt) in 1963?
Ensure brevity in your answer.  2.04e+04. What is the difference between the highest and the lowest Emissions(kt) of 1960?
Provide a short and direct response. 1.60e+04. What is the difference between the highest and the lowest Emissions(kt) of 1961?
Provide a succinct answer. 1.71e+04. What is the difference between the highest and the lowest Emissions(kt) of 1962?
Keep it short and to the point. 1.86e+04. What is the difference between the highest and the lowest Emissions(kt) in 1963?
Offer a terse response. 2.15e+04. 